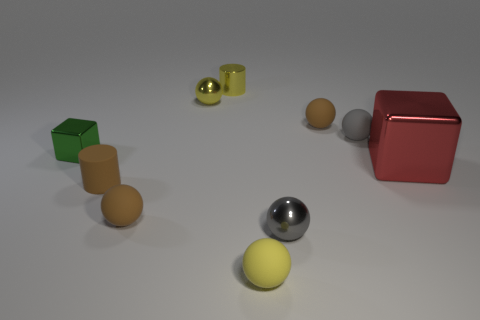Subtract all brown balls. How many balls are left? 4 Subtract all tiny yellow metal balls. How many balls are left? 5 Subtract 2 spheres. How many spheres are left? 4 Subtract all green spheres. Subtract all blue cubes. How many spheres are left? 6 Subtract all balls. How many objects are left? 4 Subtract 0 purple spheres. How many objects are left? 10 Subtract all big red matte cylinders. Subtract all yellow metallic balls. How many objects are left? 9 Add 7 shiny cubes. How many shiny cubes are left? 9 Add 6 tiny red rubber balls. How many tiny red rubber balls exist? 6 